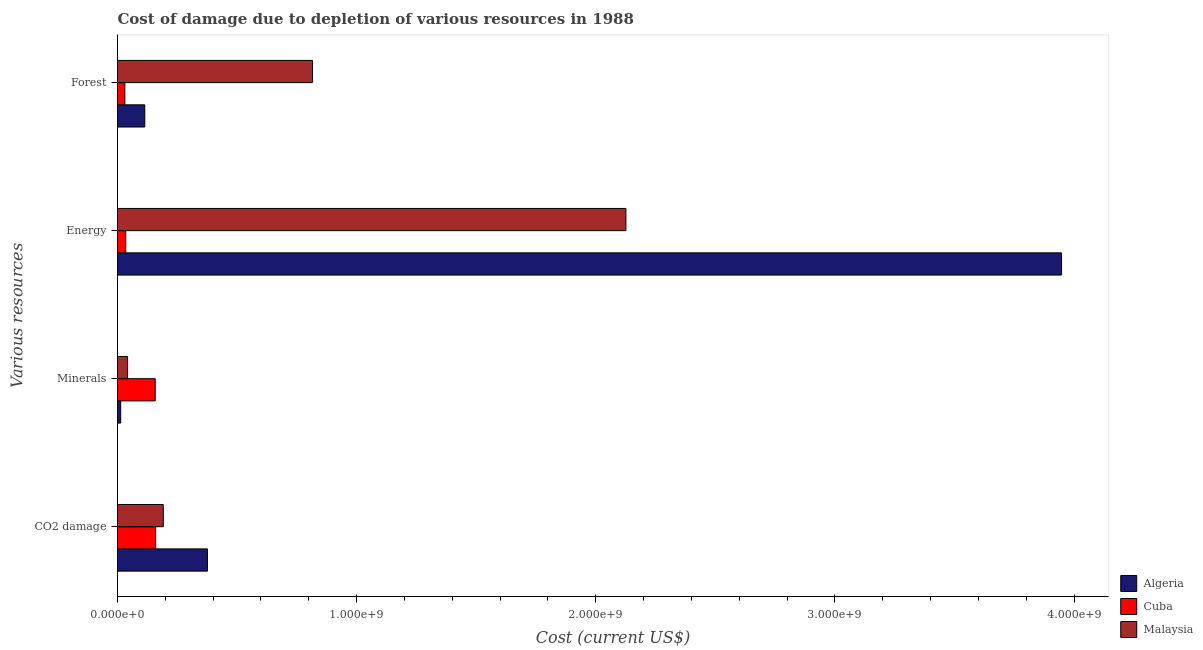What is the label of the 1st group of bars from the top?
Your answer should be compact. Forest. What is the cost of damage due to depletion of coal in Malaysia?
Your answer should be very brief. 1.91e+08. Across all countries, what is the maximum cost of damage due to depletion of forests?
Give a very brief answer. 8.15e+08. Across all countries, what is the minimum cost of damage due to depletion of coal?
Ensure brevity in your answer.  1.60e+08. In which country was the cost of damage due to depletion of forests maximum?
Give a very brief answer. Malaysia. In which country was the cost of damage due to depletion of energy minimum?
Offer a terse response. Cuba. What is the total cost of damage due to depletion of coal in the graph?
Keep it short and to the point. 7.27e+08. What is the difference between the cost of damage due to depletion of energy in Malaysia and that in Cuba?
Provide a short and direct response. 2.09e+09. What is the difference between the cost of damage due to depletion of forests in Algeria and the cost of damage due to depletion of minerals in Malaysia?
Offer a very short reply. 7.20e+07. What is the average cost of damage due to depletion of coal per country?
Make the answer very short. 2.42e+08. What is the difference between the cost of damage due to depletion of forests and cost of damage due to depletion of energy in Cuba?
Offer a terse response. -3.77e+06. In how many countries, is the cost of damage due to depletion of minerals greater than 2200000000 US$?
Your response must be concise. 0. What is the ratio of the cost of damage due to depletion of energy in Algeria to that in Cuba?
Your answer should be compact. 114.52. Is the cost of damage due to depletion of minerals in Malaysia less than that in Algeria?
Offer a very short reply. No. What is the difference between the highest and the second highest cost of damage due to depletion of forests?
Give a very brief answer. 7.01e+08. What is the difference between the highest and the lowest cost of damage due to depletion of minerals?
Make the answer very short. 1.44e+08. In how many countries, is the cost of damage due to depletion of minerals greater than the average cost of damage due to depletion of minerals taken over all countries?
Your answer should be compact. 1. Is the sum of the cost of damage due to depletion of minerals in Cuba and Algeria greater than the maximum cost of damage due to depletion of energy across all countries?
Your answer should be very brief. No. What does the 3rd bar from the top in Forest represents?
Your response must be concise. Algeria. What does the 2nd bar from the bottom in Energy represents?
Your response must be concise. Cuba. Is it the case that in every country, the sum of the cost of damage due to depletion of coal and cost of damage due to depletion of minerals is greater than the cost of damage due to depletion of energy?
Give a very brief answer. No. How many legend labels are there?
Provide a succinct answer. 3. How are the legend labels stacked?
Give a very brief answer. Vertical. What is the title of the graph?
Give a very brief answer. Cost of damage due to depletion of various resources in 1988 . Does "Marshall Islands" appear as one of the legend labels in the graph?
Your answer should be compact. No. What is the label or title of the X-axis?
Your answer should be compact. Cost (current US$). What is the label or title of the Y-axis?
Provide a succinct answer. Various resources. What is the Cost (current US$) in Algeria in CO2 damage?
Make the answer very short. 3.76e+08. What is the Cost (current US$) of Cuba in CO2 damage?
Offer a terse response. 1.60e+08. What is the Cost (current US$) in Malaysia in CO2 damage?
Make the answer very short. 1.91e+08. What is the Cost (current US$) in Algeria in Minerals?
Your answer should be compact. 1.33e+07. What is the Cost (current US$) of Cuba in Minerals?
Make the answer very short. 1.58e+08. What is the Cost (current US$) in Malaysia in Minerals?
Your answer should be compact. 4.21e+07. What is the Cost (current US$) of Algeria in Energy?
Make the answer very short. 3.95e+09. What is the Cost (current US$) of Cuba in Energy?
Provide a short and direct response. 3.45e+07. What is the Cost (current US$) in Malaysia in Energy?
Provide a short and direct response. 2.13e+09. What is the Cost (current US$) in Algeria in Forest?
Offer a very short reply. 1.14e+08. What is the Cost (current US$) of Cuba in Forest?
Provide a short and direct response. 3.07e+07. What is the Cost (current US$) of Malaysia in Forest?
Give a very brief answer. 8.15e+08. Across all Various resources, what is the maximum Cost (current US$) of Algeria?
Your answer should be compact. 3.95e+09. Across all Various resources, what is the maximum Cost (current US$) in Cuba?
Make the answer very short. 1.60e+08. Across all Various resources, what is the maximum Cost (current US$) in Malaysia?
Your answer should be compact. 2.13e+09. Across all Various resources, what is the minimum Cost (current US$) of Algeria?
Provide a short and direct response. 1.33e+07. Across all Various resources, what is the minimum Cost (current US$) in Cuba?
Offer a very short reply. 3.07e+07. Across all Various resources, what is the minimum Cost (current US$) in Malaysia?
Ensure brevity in your answer.  4.21e+07. What is the total Cost (current US$) of Algeria in the graph?
Offer a terse response. 4.45e+09. What is the total Cost (current US$) of Cuba in the graph?
Give a very brief answer. 3.82e+08. What is the total Cost (current US$) of Malaysia in the graph?
Give a very brief answer. 3.17e+09. What is the difference between the Cost (current US$) in Algeria in CO2 damage and that in Minerals?
Provide a succinct answer. 3.63e+08. What is the difference between the Cost (current US$) of Cuba in CO2 damage and that in Minerals?
Keep it short and to the point. 2.07e+06. What is the difference between the Cost (current US$) of Malaysia in CO2 damage and that in Minerals?
Offer a very short reply. 1.49e+08. What is the difference between the Cost (current US$) in Algeria in CO2 damage and that in Energy?
Ensure brevity in your answer.  -3.57e+09. What is the difference between the Cost (current US$) in Cuba in CO2 damage and that in Energy?
Offer a very short reply. 1.25e+08. What is the difference between the Cost (current US$) in Malaysia in CO2 damage and that in Energy?
Your answer should be compact. -1.93e+09. What is the difference between the Cost (current US$) in Algeria in CO2 damage and that in Forest?
Give a very brief answer. 2.62e+08. What is the difference between the Cost (current US$) of Cuba in CO2 damage and that in Forest?
Offer a very short reply. 1.29e+08. What is the difference between the Cost (current US$) of Malaysia in CO2 damage and that in Forest?
Make the answer very short. -6.24e+08. What is the difference between the Cost (current US$) in Algeria in Minerals and that in Energy?
Keep it short and to the point. -3.93e+09. What is the difference between the Cost (current US$) of Cuba in Minerals and that in Energy?
Your answer should be very brief. 1.23e+08. What is the difference between the Cost (current US$) of Malaysia in Minerals and that in Energy?
Provide a short and direct response. -2.08e+09. What is the difference between the Cost (current US$) of Algeria in Minerals and that in Forest?
Give a very brief answer. -1.01e+08. What is the difference between the Cost (current US$) of Cuba in Minerals and that in Forest?
Your answer should be very brief. 1.27e+08. What is the difference between the Cost (current US$) of Malaysia in Minerals and that in Forest?
Provide a short and direct response. -7.73e+08. What is the difference between the Cost (current US$) of Algeria in Energy and that in Forest?
Offer a very short reply. 3.83e+09. What is the difference between the Cost (current US$) in Cuba in Energy and that in Forest?
Your response must be concise. 3.77e+06. What is the difference between the Cost (current US$) of Malaysia in Energy and that in Forest?
Your response must be concise. 1.31e+09. What is the difference between the Cost (current US$) of Algeria in CO2 damage and the Cost (current US$) of Cuba in Minerals?
Offer a terse response. 2.19e+08. What is the difference between the Cost (current US$) of Algeria in CO2 damage and the Cost (current US$) of Malaysia in Minerals?
Offer a very short reply. 3.34e+08. What is the difference between the Cost (current US$) in Cuba in CO2 damage and the Cost (current US$) in Malaysia in Minerals?
Offer a very short reply. 1.18e+08. What is the difference between the Cost (current US$) in Algeria in CO2 damage and the Cost (current US$) in Cuba in Energy?
Keep it short and to the point. 3.42e+08. What is the difference between the Cost (current US$) in Algeria in CO2 damage and the Cost (current US$) in Malaysia in Energy?
Your answer should be very brief. -1.75e+09. What is the difference between the Cost (current US$) in Cuba in CO2 damage and the Cost (current US$) in Malaysia in Energy?
Give a very brief answer. -1.97e+09. What is the difference between the Cost (current US$) of Algeria in CO2 damage and the Cost (current US$) of Cuba in Forest?
Your response must be concise. 3.45e+08. What is the difference between the Cost (current US$) of Algeria in CO2 damage and the Cost (current US$) of Malaysia in Forest?
Provide a short and direct response. -4.39e+08. What is the difference between the Cost (current US$) in Cuba in CO2 damage and the Cost (current US$) in Malaysia in Forest?
Ensure brevity in your answer.  -6.56e+08. What is the difference between the Cost (current US$) in Algeria in Minerals and the Cost (current US$) in Cuba in Energy?
Your response must be concise. -2.11e+07. What is the difference between the Cost (current US$) of Algeria in Minerals and the Cost (current US$) of Malaysia in Energy?
Ensure brevity in your answer.  -2.11e+09. What is the difference between the Cost (current US$) of Cuba in Minerals and the Cost (current US$) of Malaysia in Energy?
Offer a very short reply. -1.97e+09. What is the difference between the Cost (current US$) of Algeria in Minerals and the Cost (current US$) of Cuba in Forest?
Provide a succinct answer. -1.74e+07. What is the difference between the Cost (current US$) of Algeria in Minerals and the Cost (current US$) of Malaysia in Forest?
Offer a terse response. -8.02e+08. What is the difference between the Cost (current US$) of Cuba in Minerals and the Cost (current US$) of Malaysia in Forest?
Your answer should be very brief. -6.58e+08. What is the difference between the Cost (current US$) in Algeria in Energy and the Cost (current US$) in Cuba in Forest?
Ensure brevity in your answer.  3.92e+09. What is the difference between the Cost (current US$) in Algeria in Energy and the Cost (current US$) in Malaysia in Forest?
Provide a short and direct response. 3.13e+09. What is the difference between the Cost (current US$) in Cuba in Energy and the Cost (current US$) in Malaysia in Forest?
Offer a very short reply. -7.81e+08. What is the average Cost (current US$) of Algeria per Various resources?
Your answer should be very brief. 1.11e+09. What is the average Cost (current US$) of Cuba per Various resources?
Your answer should be compact. 9.56e+07. What is the average Cost (current US$) in Malaysia per Various resources?
Give a very brief answer. 7.94e+08. What is the difference between the Cost (current US$) in Algeria and Cost (current US$) in Cuba in CO2 damage?
Give a very brief answer. 2.16e+08. What is the difference between the Cost (current US$) in Algeria and Cost (current US$) in Malaysia in CO2 damage?
Give a very brief answer. 1.85e+08. What is the difference between the Cost (current US$) in Cuba and Cost (current US$) in Malaysia in CO2 damage?
Offer a terse response. -3.18e+07. What is the difference between the Cost (current US$) of Algeria and Cost (current US$) of Cuba in Minerals?
Provide a succinct answer. -1.44e+08. What is the difference between the Cost (current US$) in Algeria and Cost (current US$) in Malaysia in Minerals?
Ensure brevity in your answer.  -2.88e+07. What is the difference between the Cost (current US$) of Cuba and Cost (current US$) of Malaysia in Minerals?
Make the answer very short. 1.15e+08. What is the difference between the Cost (current US$) of Algeria and Cost (current US$) of Cuba in Energy?
Give a very brief answer. 3.91e+09. What is the difference between the Cost (current US$) in Algeria and Cost (current US$) in Malaysia in Energy?
Make the answer very short. 1.82e+09. What is the difference between the Cost (current US$) in Cuba and Cost (current US$) in Malaysia in Energy?
Provide a succinct answer. -2.09e+09. What is the difference between the Cost (current US$) in Algeria and Cost (current US$) in Cuba in Forest?
Keep it short and to the point. 8.34e+07. What is the difference between the Cost (current US$) in Algeria and Cost (current US$) in Malaysia in Forest?
Provide a succinct answer. -7.01e+08. What is the difference between the Cost (current US$) in Cuba and Cost (current US$) in Malaysia in Forest?
Provide a short and direct response. -7.85e+08. What is the ratio of the Cost (current US$) in Algeria in CO2 damage to that in Minerals?
Ensure brevity in your answer.  28.19. What is the ratio of the Cost (current US$) in Cuba in CO2 damage to that in Minerals?
Provide a succinct answer. 1.01. What is the ratio of the Cost (current US$) of Malaysia in CO2 damage to that in Minerals?
Provide a succinct answer. 4.54. What is the ratio of the Cost (current US$) of Algeria in CO2 damage to that in Energy?
Give a very brief answer. 0.1. What is the ratio of the Cost (current US$) in Cuba in CO2 damage to that in Energy?
Provide a succinct answer. 4.63. What is the ratio of the Cost (current US$) of Malaysia in CO2 damage to that in Energy?
Your answer should be compact. 0.09. What is the ratio of the Cost (current US$) in Algeria in CO2 damage to that in Forest?
Offer a very short reply. 3.3. What is the ratio of the Cost (current US$) of Cuba in CO2 damage to that in Forest?
Your response must be concise. 5.2. What is the ratio of the Cost (current US$) of Malaysia in CO2 damage to that in Forest?
Give a very brief answer. 0.23. What is the ratio of the Cost (current US$) of Algeria in Minerals to that in Energy?
Your response must be concise. 0. What is the ratio of the Cost (current US$) of Cuba in Minerals to that in Energy?
Provide a succinct answer. 4.57. What is the ratio of the Cost (current US$) in Malaysia in Minerals to that in Energy?
Provide a short and direct response. 0.02. What is the ratio of the Cost (current US$) in Algeria in Minerals to that in Forest?
Ensure brevity in your answer.  0.12. What is the ratio of the Cost (current US$) of Cuba in Minerals to that in Forest?
Offer a very short reply. 5.13. What is the ratio of the Cost (current US$) of Malaysia in Minerals to that in Forest?
Offer a very short reply. 0.05. What is the ratio of the Cost (current US$) in Algeria in Energy to that in Forest?
Provide a succinct answer. 34.6. What is the ratio of the Cost (current US$) in Cuba in Energy to that in Forest?
Offer a terse response. 1.12. What is the ratio of the Cost (current US$) in Malaysia in Energy to that in Forest?
Offer a terse response. 2.61. What is the difference between the highest and the second highest Cost (current US$) in Algeria?
Your response must be concise. 3.57e+09. What is the difference between the highest and the second highest Cost (current US$) of Cuba?
Provide a succinct answer. 2.07e+06. What is the difference between the highest and the second highest Cost (current US$) in Malaysia?
Keep it short and to the point. 1.31e+09. What is the difference between the highest and the lowest Cost (current US$) of Algeria?
Your response must be concise. 3.93e+09. What is the difference between the highest and the lowest Cost (current US$) in Cuba?
Keep it short and to the point. 1.29e+08. What is the difference between the highest and the lowest Cost (current US$) of Malaysia?
Ensure brevity in your answer.  2.08e+09. 